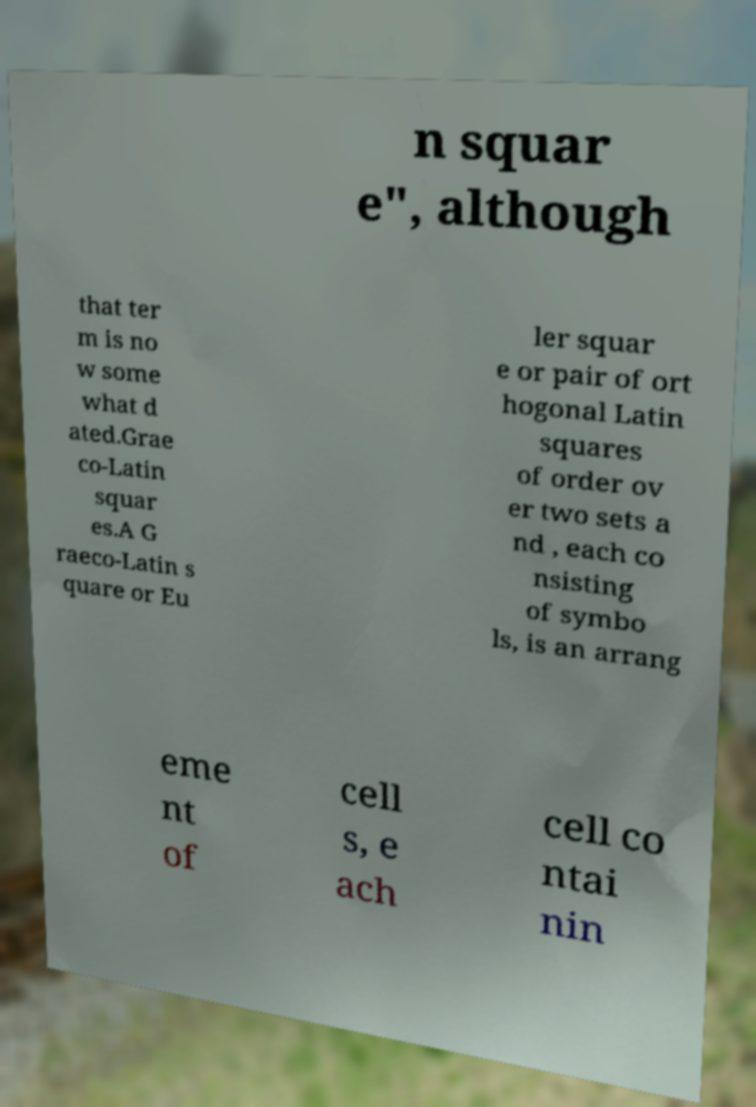Can you read and provide the text displayed in the image?This photo seems to have some interesting text. Can you extract and type it out for me? n squar e", although that ter m is no w some what d ated.Grae co-Latin squar es.A G raeco-Latin s quare or Eu ler squar e or pair of ort hogonal Latin squares of order ov er two sets a nd , each co nsisting of symbo ls, is an arrang eme nt of cell s, e ach cell co ntai nin 